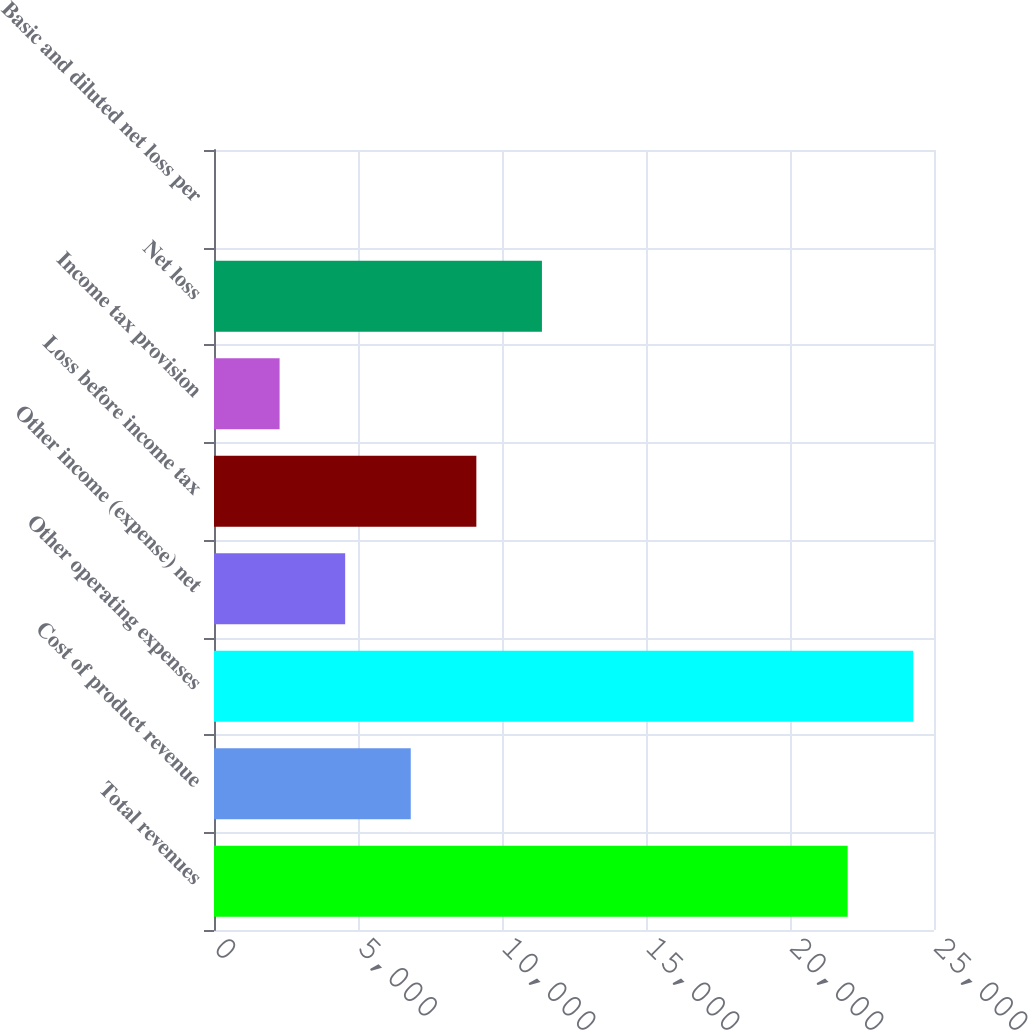Convert chart to OTSL. <chart><loc_0><loc_0><loc_500><loc_500><bar_chart><fcel>Total revenues<fcel>Cost of product revenue<fcel>Other operating expenses<fcel>Other income (expense) net<fcel>Loss before income tax<fcel>Income tax provision<fcel>Net loss<fcel>Basic and diluted net loss per<nl><fcel>22002<fcel>6832<fcel>24279.3<fcel>4554.72<fcel>9109.28<fcel>2277.44<fcel>11386.6<fcel>0.16<nl></chart> 